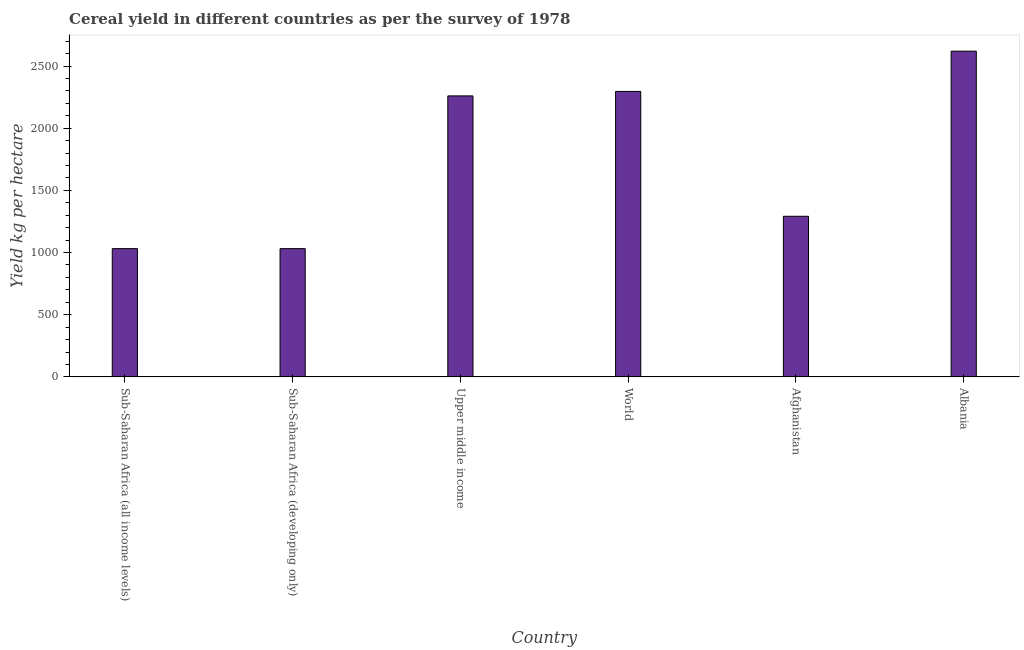Does the graph contain grids?
Give a very brief answer. No. What is the title of the graph?
Your answer should be very brief. Cereal yield in different countries as per the survey of 1978. What is the label or title of the X-axis?
Provide a succinct answer. Country. What is the label or title of the Y-axis?
Provide a short and direct response. Yield kg per hectare. What is the cereal yield in World?
Make the answer very short. 2296.36. Across all countries, what is the maximum cereal yield?
Your answer should be compact. 2620.22. Across all countries, what is the minimum cereal yield?
Ensure brevity in your answer.  1031.64. In which country was the cereal yield maximum?
Give a very brief answer. Albania. In which country was the cereal yield minimum?
Provide a short and direct response. Sub-Saharan Africa (all income levels). What is the sum of the cereal yield?
Keep it short and to the point. 1.05e+04. What is the difference between the cereal yield in Sub-Saharan Africa (all income levels) and Upper middle income?
Provide a succinct answer. -1228.66. What is the average cereal yield per country?
Offer a very short reply. 1755.34. What is the median cereal yield?
Your response must be concise. 1776.09. What is the ratio of the cereal yield in Afghanistan to that in Sub-Saharan Africa (developing only)?
Offer a terse response. 1.25. What is the difference between the highest and the second highest cereal yield?
Your answer should be very brief. 323.87. Is the sum of the cereal yield in Albania and World greater than the maximum cereal yield across all countries?
Offer a very short reply. Yes. What is the difference between the highest and the lowest cereal yield?
Offer a very short reply. 1588.58. In how many countries, is the cereal yield greater than the average cereal yield taken over all countries?
Your answer should be very brief. 3. How many bars are there?
Your answer should be compact. 6. Are all the bars in the graph horizontal?
Give a very brief answer. No. What is the Yield kg per hectare of Sub-Saharan Africa (all income levels)?
Ensure brevity in your answer.  1031.64. What is the Yield kg per hectare in Sub-Saharan Africa (developing only)?
Provide a short and direct response. 1031.64. What is the Yield kg per hectare of Upper middle income?
Ensure brevity in your answer.  2260.31. What is the Yield kg per hectare in World?
Your response must be concise. 2296.36. What is the Yield kg per hectare of Afghanistan?
Offer a very short reply. 1291.86. What is the Yield kg per hectare in Albania?
Offer a terse response. 2620.22. What is the difference between the Yield kg per hectare in Sub-Saharan Africa (all income levels) and Sub-Saharan Africa (developing only)?
Ensure brevity in your answer.  0. What is the difference between the Yield kg per hectare in Sub-Saharan Africa (all income levels) and Upper middle income?
Ensure brevity in your answer.  -1228.66. What is the difference between the Yield kg per hectare in Sub-Saharan Africa (all income levels) and World?
Provide a succinct answer. -1264.71. What is the difference between the Yield kg per hectare in Sub-Saharan Africa (all income levels) and Afghanistan?
Give a very brief answer. -260.22. What is the difference between the Yield kg per hectare in Sub-Saharan Africa (all income levels) and Albania?
Provide a short and direct response. -1588.58. What is the difference between the Yield kg per hectare in Sub-Saharan Africa (developing only) and Upper middle income?
Your answer should be compact. -1228.66. What is the difference between the Yield kg per hectare in Sub-Saharan Africa (developing only) and World?
Offer a terse response. -1264.71. What is the difference between the Yield kg per hectare in Sub-Saharan Africa (developing only) and Afghanistan?
Provide a short and direct response. -260.22. What is the difference between the Yield kg per hectare in Sub-Saharan Africa (developing only) and Albania?
Your answer should be compact. -1588.58. What is the difference between the Yield kg per hectare in Upper middle income and World?
Ensure brevity in your answer.  -36.05. What is the difference between the Yield kg per hectare in Upper middle income and Afghanistan?
Your answer should be very brief. 968.44. What is the difference between the Yield kg per hectare in Upper middle income and Albania?
Your answer should be compact. -359.92. What is the difference between the Yield kg per hectare in World and Afghanistan?
Provide a succinct answer. 1004.5. What is the difference between the Yield kg per hectare in World and Albania?
Make the answer very short. -323.87. What is the difference between the Yield kg per hectare in Afghanistan and Albania?
Your response must be concise. -1328.36. What is the ratio of the Yield kg per hectare in Sub-Saharan Africa (all income levels) to that in Upper middle income?
Keep it short and to the point. 0.46. What is the ratio of the Yield kg per hectare in Sub-Saharan Africa (all income levels) to that in World?
Offer a terse response. 0.45. What is the ratio of the Yield kg per hectare in Sub-Saharan Africa (all income levels) to that in Afghanistan?
Your response must be concise. 0.8. What is the ratio of the Yield kg per hectare in Sub-Saharan Africa (all income levels) to that in Albania?
Ensure brevity in your answer.  0.39. What is the ratio of the Yield kg per hectare in Sub-Saharan Africa (developing only) to that in Upper middle income?
Provide a succinct answer. 0.46. What is the ratio of the Yield kg per hectare in Sub-Saharan Africa (developing only) to that in World?
Your answer should be compact. 0.45. What is the ratio of the Yield kg per hectare in Sub-Saharan Africa (developing only) to that in Afghanistan?
Offer a very short reply. 0.8. What is the ratio of the Yield kg per hectare in Sub-Saharan Africa (developing only) to that in Albania?
Make the answer very short. 0.39. What is the ratio of the Yield kg per hectare in Upper middle income to that in World?
Make the answer very short. 0.98. What is the ratio of the Yield kg per hectare in Upper middle income to that in Albania?
Your answer should be compact. 0.86. What is the ratio of the Yield kg per hectare in World to that in Afghanistan?
Offer a terse response. 1.78. What is the ratio of the Yield kg per hectare in World to that in Albania?
Make the answer very short. 0.88. What is the ratio of the Yield kg per hectare in Afghanistan to that in Albania?
Ensure brevity in your answer.  0.49. 